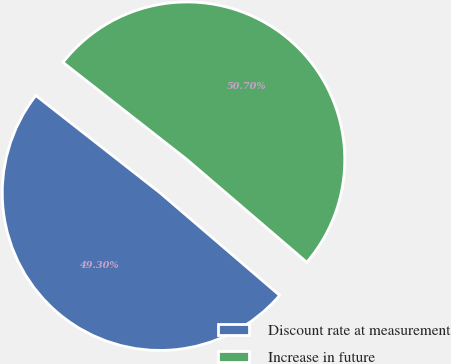Convert chart. <chart><loc_0><loc_0><loc_500><loc_500><pie_chart><fcel>Discount rate at measurement<fcel>Increase in future<nl><fcel>49.3%<fcel>50.7%<nl></chart> 